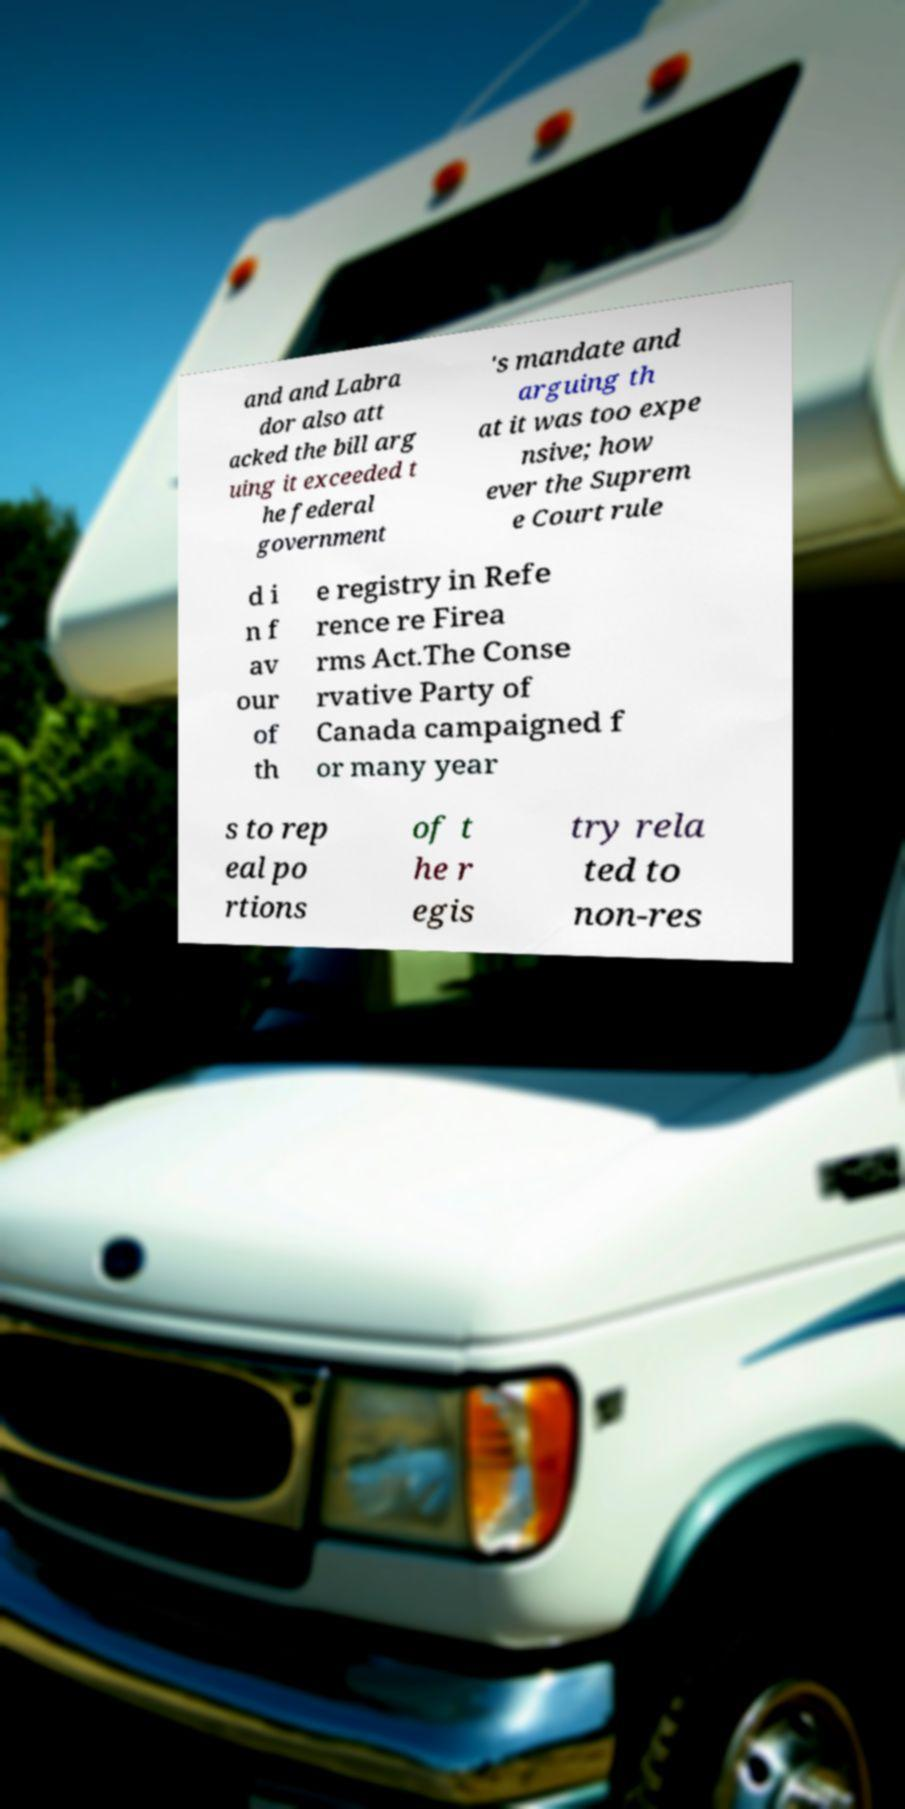What messages or text are displayed in this image? I need them in a readable, typed format. and and Labra dor also att acked the bill arg uing it exceeded t he federal government 's mandate and arguing th at it was too expe nsive; how ever the Suprem e Court rule d i n f av our of th e registry in Refe rence re Firea rms Act.The Conse rvative Party of Canada campaigned f or many year s to rep eal po rtions of t he r egis try rela ted to non-res 